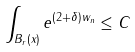<formula> <loc_0><loc_0><loc_500><loc_500>\int _ { B _ { r } ( x ) } e ^ { ( 2 + \delta ) w _ { n } } \leq C</formula> 